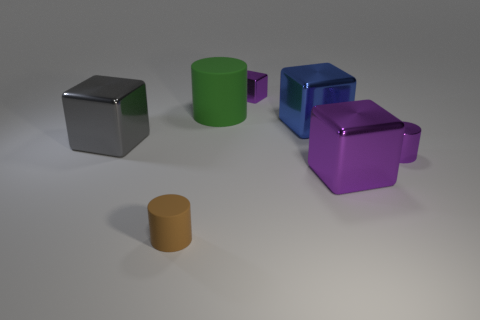Subtract all red cubes. Subtract all blue cylinders. How many cubes are left? 4 Add 2 brown metallic cubes. How many objects exist? 9 Subtract all blocks. How many objects are left? 3 Subtract 1 purple cylinders. How many objects are left? 6 Subtract all tiny brown objects. Subtract all cubes. How many objects are left? 2 Add 7 big blocks. How many big blocks are left? 10 Add 5 large blue cubes. How many large blue cubes exist? 6 